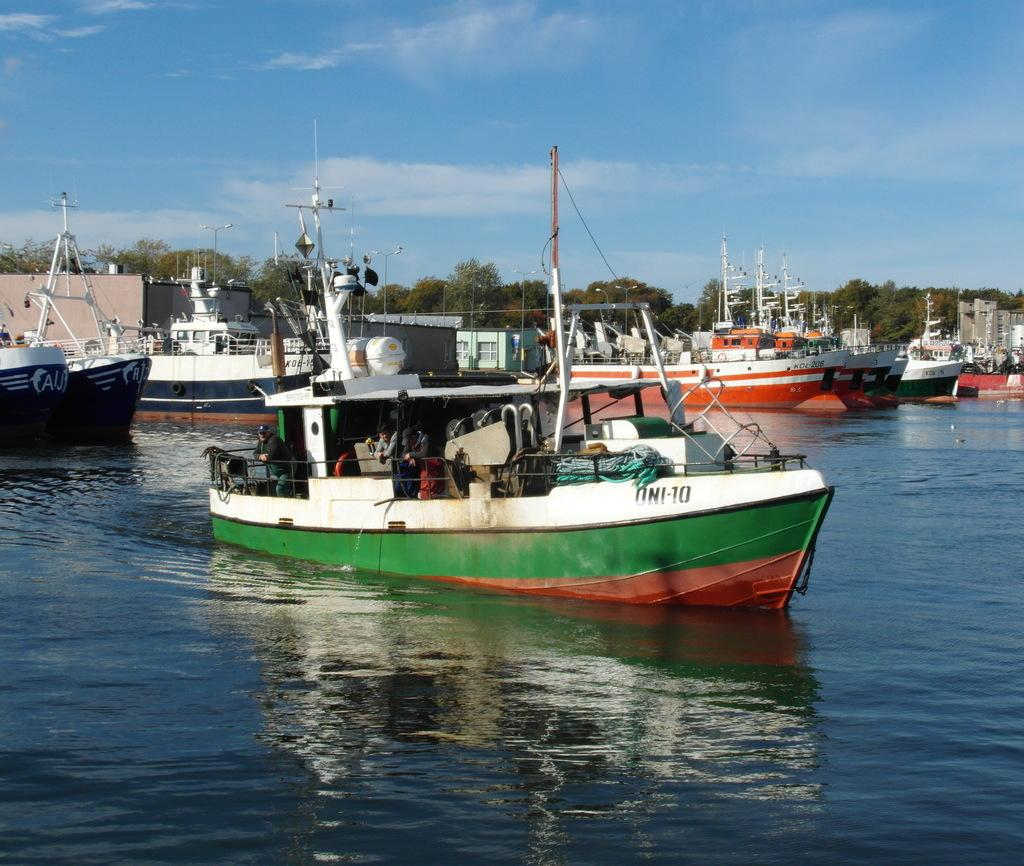What is the primary element in the image? There is water in the image. What is floating on the water? There are boats in the water. What can be seen in the background of the image? There are trees and clouds in the background of the image. What part of the natural environment is visible in the image? The sky is visible in the background of the image. How many dogs are sitting on the straw in the image? There are no dogs or straw present in the image. 